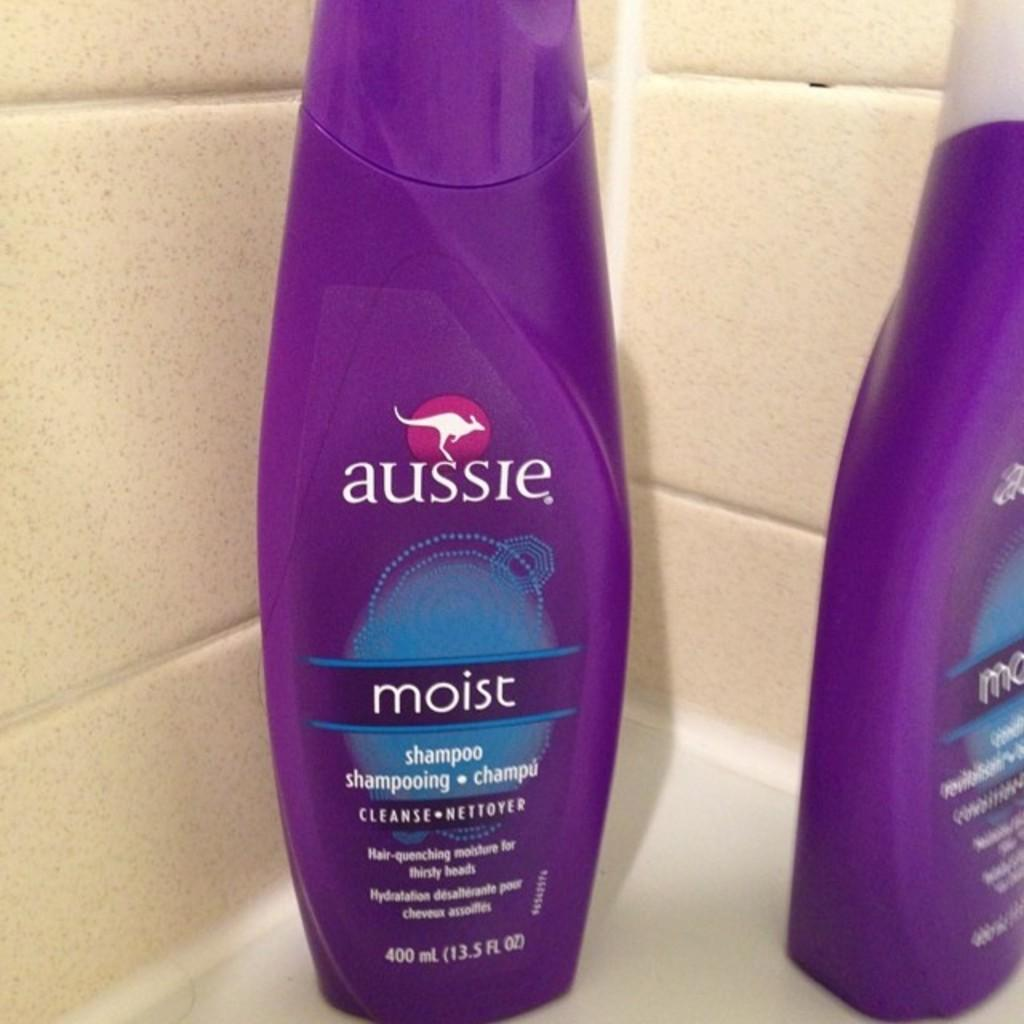How many bottles can be seen in the image? There are two bottles in the image. What type of bottle is the first one? The first bottle is a shampoo bottle. What can be seen behind the bottles? There are tiles visible behind the bottles. What type of work is the shampoo bottle doing in the image? The shampoo bottle is not performing any work in the image; it is simply a stationary object. 